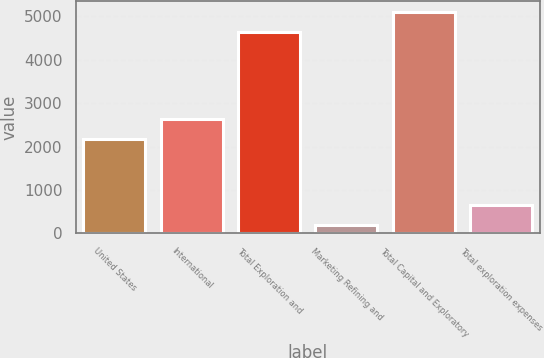<chart> <loc_0><loc_0><loc_500><loc_500><bar_chart><fcel>United States<fcel>International<fcel>Total Exploration and<fcel>Marketing Refining and<fcel>Total Capital and Exploratory<fcel>Total exploration expenses<nl><fcel>2164<fcel>2628.1<fcel>4641<fcel>187<fcel>5105.1<fcel>651.1<nl></chart> 